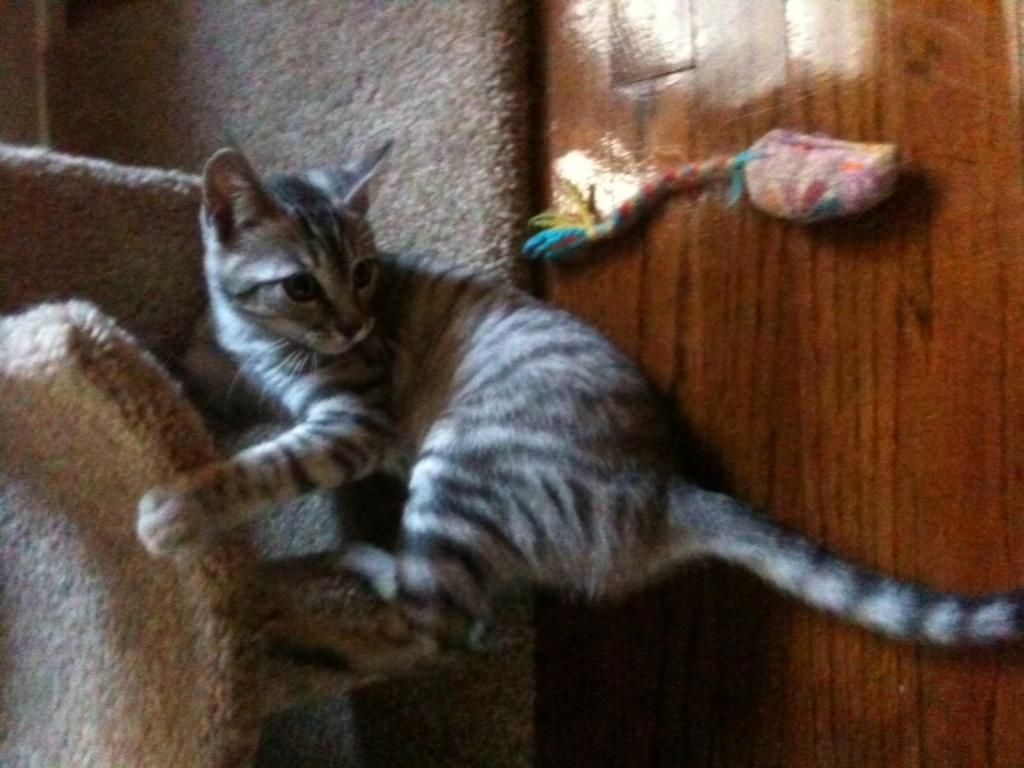What type of animal is in the image? There is a cat in the image. Where is the cat located in relation to other objects? The cat is near cloth on the floor. What can be seen behind the cat? There is an object behind the cat. What type of garden can be seen in the background of the image? There is no garden visible in the image; it only shows a cat near cloth on the floor and an object behind the cat. 